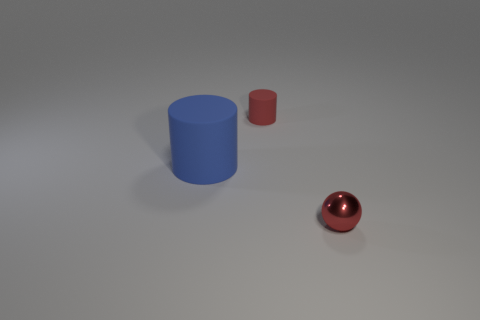Add 3 shiny things. How many objects exist? 6 Subtract 2 cylinders. How many cylinders are left? 0 Subtract all cylinders. How many objects are left? 1 Subtract all cyan cylinders. Subtract all green cubes. How many cylinders are left? 2 Subtract all cyan spheres. How many blue cylinders are left? 1 Subtract all big rubber objects. Subtract all big gray rubber cubes. How many objects are left? 2 Add 1 small red balls. How many small red balls are left? 2 Add 1 tiny red shiny spheres. How many tiny red shiny spheres exist? 2 Subtract all blue cylinders. How many cylinders are left? 1 Subtract 0 purple balls. How many objects are left? 3 